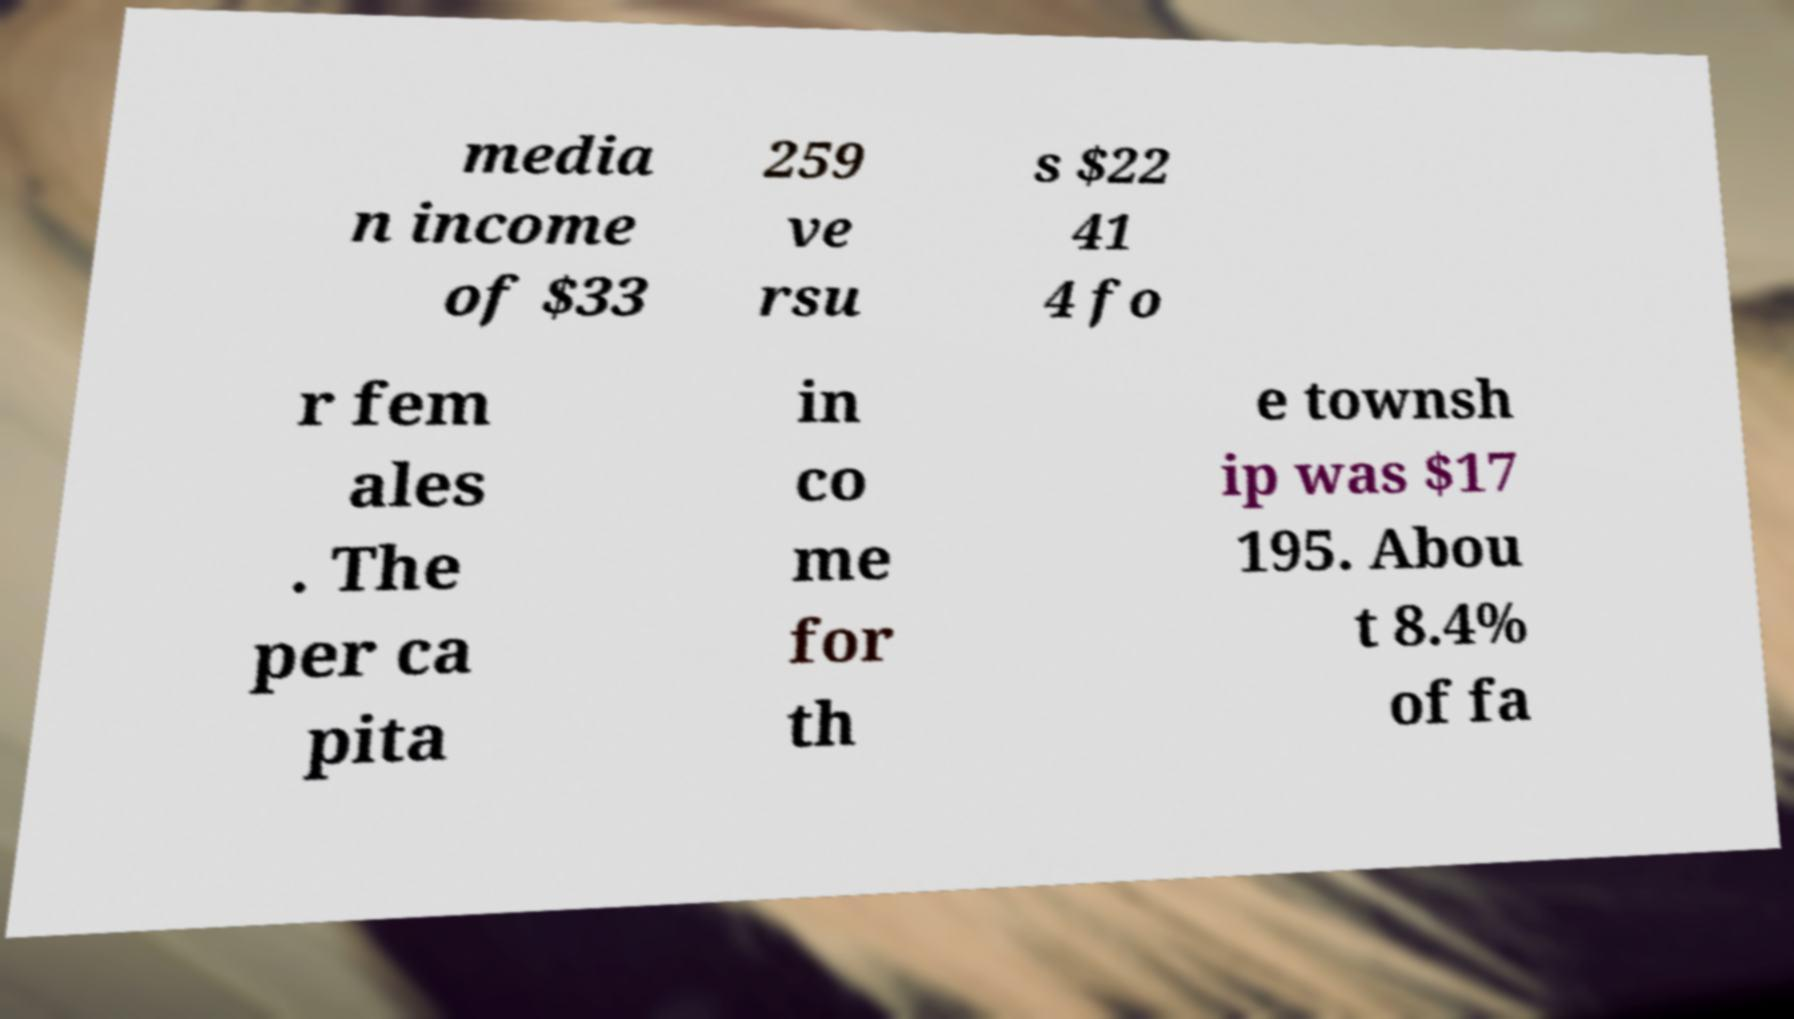I need the written content from this picture converted into text. Can you do that? media n income of $33 259 ve rsu s $22 41 4 fo r fem ales . The per ca pita in co me for th e townsh ip was $17 195. Abou t 8.4% of fa 